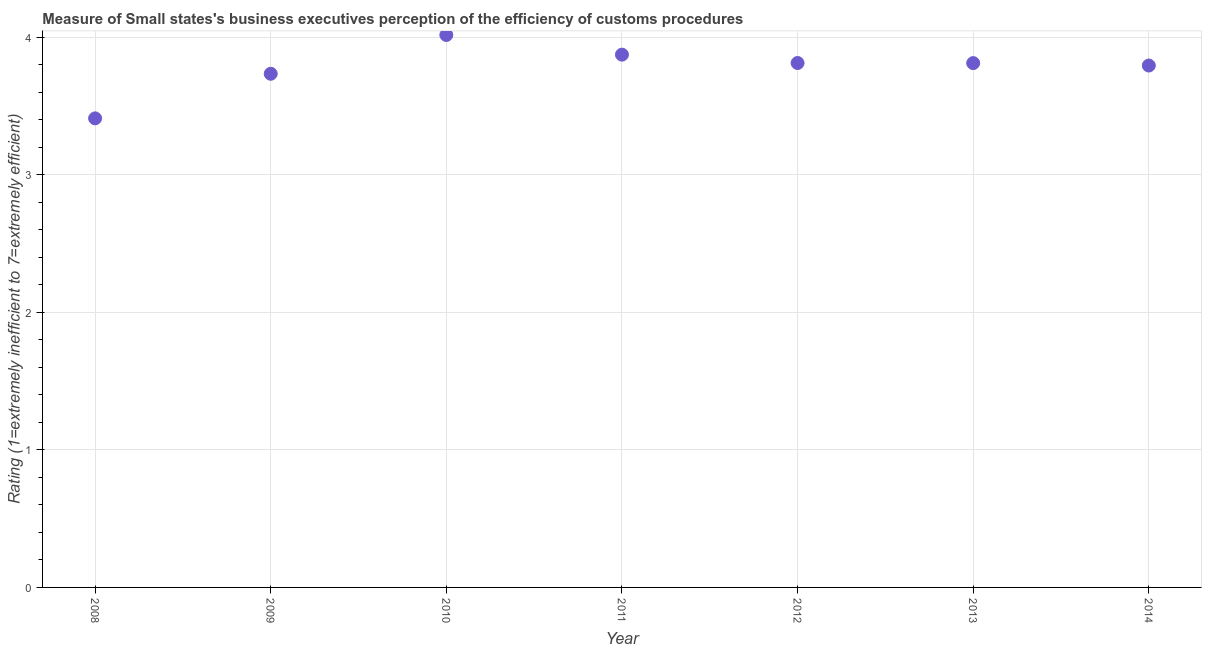What is the rating measuring burden of customs procedure in 2012?
Your answer should be very brief. 3.81. Across all years, what is the maximum rating measuring burden of customs procedure?
Your answer should be very brief. 4.02. Across all years, what is the minimum rating measuring burden of customs procedure?
Provide a succinct answer. 3.41. In which year was the rating measuring burden of customs procedure maximum?
Offer a terse response. 2010. In which year was the rating measuring burden of customs procedure minimum?
Give a very brief answer. 2008. What is the sum of the rating measuring burden of customs procedure?
Your response must be concise. 26.45. What is the difference between the rating measuring burden of customs procedure in 2010 and 2011?
Give a very brief answer. 0.14. What is the average rating measuring burden of customs procedure per year?
Your answer should be compact. 3.78. What is the median rating measuring burden of customs procedure?
Make the answer very short. 3.81. In how many years, is the rating measuring burden of customs procedure greater than 0.8 ?
Your answer should be very brief. 7. Do a majority of the years between 2009 and 2010 (inclusive) have rating measuring burden of customs procedure greater than 2.6 ?
Your answer should be compact. Yes. What is the ratio of the rating measuring burden of customs procedure in 2012 to that in 2013?
Ensure brevity in your answer.  1. Is the rating measuring burden of customs procedure in 2008 less than that in 2012?
Your response must be concise. Yes. What is the difference between the highest and the second highest rating measuring burden of customs procedure?
Provide a short and direct response. 0.14. What is the difference between the highest and the lowest rating measuring burden of customs procedure?
Offer a very short reply. 0.61. What is the difference between two consecutive major ticks on the Y-axis?
Your answer should be compact. 1. Does the graph contain any zero values?
Make the answer very short. No. What is the title of the graph?
Give a very brief answer. Measure of Small states's business executives perception of the efficiency of customs procedures. What is the label or title of the Y-axis?
Make the answer very short. Rating (1=extremely inefficient to 7=extremely efficient). What is the Rating (1=extremely inefficient to 7=extremely efficient) in 2008?
Offer a very short reply. 3.41. What is the Rating (1=extremely inefficient to 7=extremely efficient) in 2009?
Offer a terse response. 3.73. What is the Rating (1=extremely inefficient to 7=extremely efficient) in 2010?
Keep it short and to the point. 4.02. What is the Rating (1=extremely inefficient to 7=extremely efficient) in 2011?
Your answer should be very brief. 3.87. What is the Rating (1=extremely inefficient to 7=extremely efficient) in 2012?
Provide a succinct answer. 3.81. What is the Rating (1=extremely inefficient to 7=extremely efficient) in 2013?
Keep it short and to the point. 3.81. What is the Rating (1=extremely inefficient to 7=extremely efficient) in 2014?
Make the answer very short. 3.79. What is the difference between the Rating (1=extremely inefficient to 7=extremely efficient) in 2008 and 2009?
Offer a very short reply. -0.32. What is the difference between the Rating (1=extremely inefficient to 7=extremely efficient) in 2008 and 2010?
Give a very brief answer. -0.61. What is the difference between the Rating (1=extremely inefficient to 7=extremely efficient) in 2008 and 2011?
Make the answer very short. -0.46. What is the difference between the Rating (1=extremely inefficient to 7=extremely efficient) in 2008 and 2012?
Your answer should be compact. -0.4. What is the difference between the Rating (1=extremely inefficient to 7=extremely efficient) in 2008 and 2013?
Your answer should be compact. -0.4. What is the difference between the Rating (1=extremely inefficient to 7=extremely efficient) in 2008 and 2014?
Provide a succinct answer. -0.38. What is the difference between the Rating (1=extremely inefficient to 7=extremely efficient) in 2009 and 2010?
Provide a short and direct response. -0.28. What is the difference between the Rating (1=extremely inefficient to 7=extremely efficient) in 2009 and 2011?
Provide a succinct answer. -0.14. What is the difference between the Rating (1=extremely inefficient to 7=extremely efficient) in 2009 and 2012?
Offer a terse response. -0.08. What is the difference between the Rating (1=extremely inefficient to 7=extremely efficient) in 2009 and 2013?
Offer a terse response. -0.08. What is the difference between the Rating (1=extremely inefficient to 7=extremely efficient) in 2009 and 2014?
Ensure brevity in your answer.  -0.06. What is the difference between the Rating (1=extremely inefficient to 7=extremely efficient) in 2010 and 2011?
Give a very brief answer. 0.14. What is the difference between the Rating (1=extremely inefficient to 7=extremely efficient) in 2010 and 2012?
Make the answer very short. 0.2. What is the difference between the Rating (1=extremely inefficient to 7=extremely efficient) in 2010 and 2013?
Ensure brevity in your answer.  0.2. What is the difference between the Rating (1=extremely inefficient to 7=extremely efficient) in 2010 and 2014?
Keep it short and to the point. 0.22. What is the difference between the Rating (1=extremely inefficient to 7=extremely efficient) in 2011 and 2012?
Ensure brevity in your answer.  0.06. What is the difference between the Rating (1=extremely inefficient to 7=extremely efficient) in 2011 and 2013?
Make the answer very short. 0.06. What is the difference between the Rating (1=extremely inefficient to 7=extremely efficient) in 2011 and 2014?
Your response must be concise. 0.08. What is the difference between the Rating (1=extremely inefficient to 7=extremely efficient) in 2012 and 2013?
Offer a very short reply. 0. What is the difference between the Rating (1=extremely inefficient to 7=extremely efficient) in 2012 and 2014?
Provide a succinct answer. 0.02. What is the difference between the Rating (1=extremely inefficient to 7=extremely efficient) in 2013 and 2014?
Keep it short and to the point. 0.02. What is the ratio of the Rating (1=extremely inefficient to 7=extremely efficient) in 2008 to that in 2010?
Offer a very short reply. 0.85. What is the ratio of the Rating (1=extremely inefficient to 7=extremely efficient) in 2008 to that in 2012?
Provide a succinct answer. 0.89. What is the ratio of the Rating (1=extremely inefficient to 7=extremely efficient) in 2008 to that in 2013?
Ensure brevity in your answer.  0.9. What is the ratio of the Rating (1=extremely inefficient to 7=extremely efficient) in 2008 to that in 2014?
Ensure brevity in your answer.  0.9. What is the ratio of the Rating (1=extremely inefficient to 7=extremely efficient) in 2009 to that in 2011?
Provide a succinct answer. 0.96. What is the ratio of the Rating (1=extremely inefficient to 7=extremely efficient) in 2009 to that in 2012?
Offer a very short reply. 0.98. What is the ratio of the Rating (1=extremely inefficient to 7=extremely efficient) in 2009 to that in 2013?
Keep it short and to the point. 0.98. What is the ratio of the Rating (1=extremely inefficient to 7=extremely efficient) in 2009 to that in 2014?
Give a very brief answer. 0.98. What is the ratio of the Rating (1=extremely inefficient to 7=extremely efficient) in 2010 to that in 2012?
Your answer should be very brief. 1.05. What is the ratio of the Rating (1=extremely inefficient to 7=extremely efficient) in 2010 to that in 2013?
Offer a terse response. 1.05. What is the ratio of the Rating (1=extremely inefficient to 7=extremely efficient) in 2010 to that in 2014?
Your answer should be compact. 1.06. What is the ratio of the Rating (1=extremely inefficient to 7=extremely efficient) in 2011 to that in 2012?
Offer a very short reply. 1.02. What is the ratio of the Rating (1=extremely inefficient to 7=extremely efficient) in 2012 to that in 2014?
Keep it short and to the point. 1. What is the ratio of the Rating (1=extremely inefficient to 7=extremely efficient) in 2013 to that in 2014?
Keep it short and to the point. 1. 